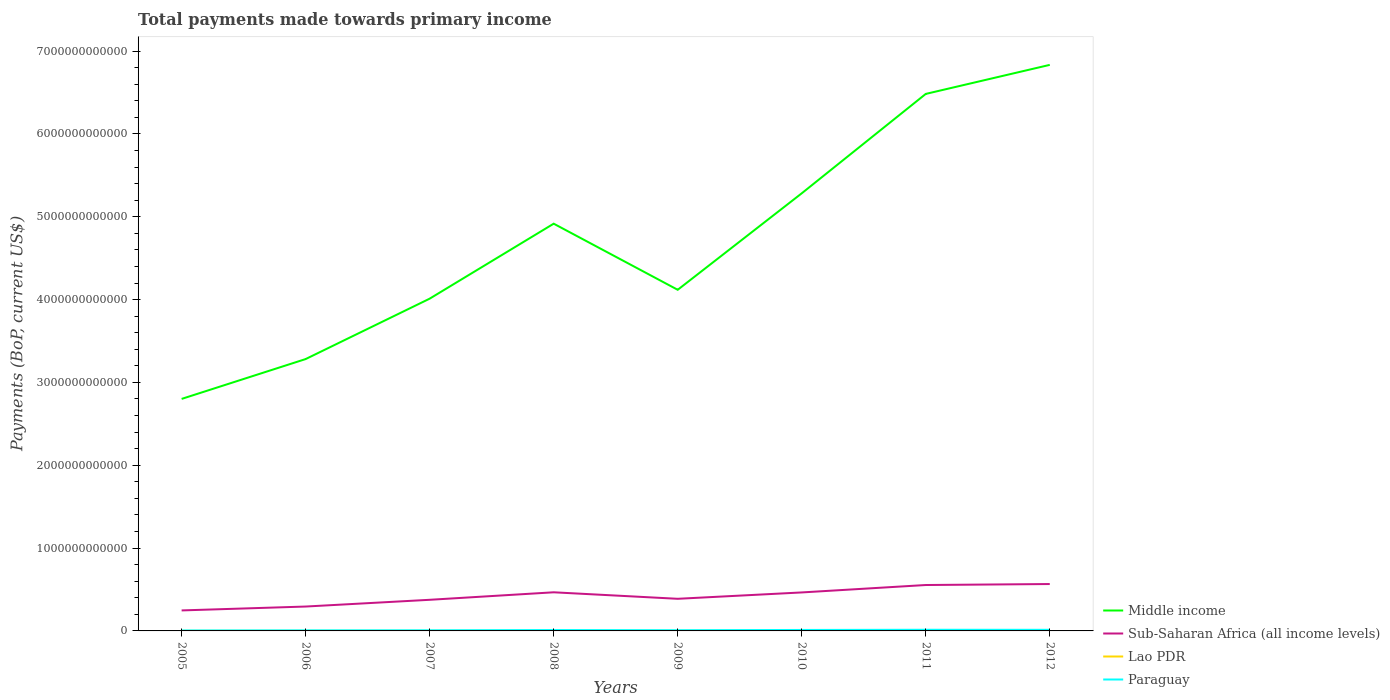How many different coloured lines are there?
Your answer should be compact. 4. Does the line corresponding to Middle income intersect with the line corresponding to Paraguay?
Offer a terse response. No. Across all years, what is the maximum total payments made towards primary income in Sub-Saharan Africa (all income levels)?
Provide a succinct answer. 2.47e+11. In which year was the total payments made towards primary income in Lao PDR maximum?
Make the answer very short. 2005. What is the total total payments made towards primary income in Lao PDR in the graph?
Make the answer very short. -1.12e+09. What is the difference between the highest and the second highest total payments made towards primary income in Middle income?
Your answer should be compact. 4.03e+12. Is the total payments made towards primary income in Middle income strictly greater than the total payments made towards primary income in Lao PDR over the years?
Offer a very short reply. No. How many years are there in the graph?
Offer a very short reply. 8. What is the difference between two consecutive major ticks on the Y-axis?
Offer a very short reply. 1.00e+12. Are the values on the major ticks of Y-axis written in scientific E-notation?
Your response must be concise. No. Does the graph contain grids?
Keep it short and to the point. No. How many legend labels are there?
Make the answer very short. 4. What is the title of the graph?
Your answer should be very brief. Total payments made towards primary income. Does "Poland" appear as one of the legend labels in the graph?
Your response must be concise. No. What is the label or title of the X-axis?
Your response must be concise. Years. What is the label or title of the Y-axis?
Ensure brevity in your answer.  Payments (BoP, current US$). What is the Payments (BoP, current US$) of Middle income in 2005?
Give a very brief answer. 2.80e+12. What is the Payments (BoP, current US$) of Sub-Saharan Africa (all income levels) in 2005?
Your answer should be compact. 2.47e+11. What is the Payments (BoP, current US$) in Lao PDR in 2005?
Provide a short and direct response. 1.00e+09. What is the Payments (BoP, current US$) in Paraguay in 2005?
Your answer should be very brief. 5.47e+09. What is the Payments (BoP, current US$) in Middle income in 2006?
Keep it short and to the point. 3.28e+12. What is the Payments (BoP, current US$) of Sub-Saharan Africa (all income levels) in 2006?
Provide a succinct answer. 2.94e+11. What is the Payments (BoP, current US$) in Lao PDR in 2006?
Give a very brief answer. 1.17e+09. What is the Payments (BoP, current US$) of Paraguay in 2006?
Your answer should be very brief. 6.70e+09. What is the Payments (BoP, current US$) in Middle income in 2007?
Keep it short and to the point. 4.01e+12. What is the Payments (BoP, current US$) of Sub-Saharan Africa (all income levels) in 2007?
Ensure brevity in your answer.  3.76e+11. What is the Payments (BoP, current US$) of Lao PDR in 2007?
Make the answer very short. 1.20e+09. What is the Payments (BoP, current US$) in Paraguay in 2007?
Keep it short and to the point. 7.56e+09. What is the Payments (BoP, current US$) of Middle income in 2008?
Make the answer very short. 4.92e+12. What is the Payments (BoP, current US$) of Sub-Saharan Africa (all income levels) in 2008?
Make the answer very short. 4.66e+11. What is the Payments (BoP, current US$) of Lao PDR in 2008?
Your answer should be compact. 1.59e+09. What is the Payments (BoP, current US$) of Paraguay in 2008?
Make the answer very short. 1.05e+1. What is the Payments (BoP, current US$) in Middle income in 2009?
Your response must be concise. 4.12e+12. What is the Payments (BoP, current US$) of Sub-Saharan Africa (all income levels) in 2009?
Make the answer very short. 3.88e+11. What is the Payments (BoP, current US$) in Lao PDR in 2009?
Keep it short and to the point. 1.69e+09. What is the Payments (BoP, current US$) of Paraguay in 2009?
Provide a succinct answer. 8.42e+09. What is the Payments (BoP, current US$) of Middle income in 2010?
Provide a succinct answer. 5.28e+12. What is the Payments (BoP, current US$) of Sub-Saharan Africa (all income levels) in 2010?
Offer a terse response. 4.65e+11. What is the Payments (BoP, current US$) in Lao PDR in 2010?
Offer a very short reply. 2.46e+09. What is the Payments (BoP, current US$) in Paraguay in 2010?
Give a very brief answer. 1.17e+1. What is the Payments (BoP, current US$) of Middle income in 2011?
Provide a short and direct response. 6.48e+12. What is the Payments (BoP, current US$) of Sub-Saharan Africa (all income levels) in 2011?
Give a very brief answer. 5.54e+11. What is the Payments (BoP, current US$) in Lao PDR in 2011?
Provide a short and direct response. 2.88e+09. What is the Payments (BoP, current US$) of Paraguay in 2011?
Make the answer very short. 1.39e+1. What is the Payments (BoP, current US$) of Middle income in 2012?
Make the answer very short. 6.83e+12. What is the Payments (BoP, current US$) of Sub-Saharan Africa (all income levels) in 2012?
Offer a very short reply. 5.66e+11. What is the Payments (BoP, current US$) of Lao PDR in 2012?
Your answer should be very brief. 3.58e+09. What is the Payments (BoP, current US$) of Paraguay in 2012?
Offer a very short reply. 1.34e+1. Across all years, what is the maximum Payments (BoP, current US$) of Middle income?
Ensure brevity in your answer.  6.83e+12. Across all years, what is the maximum Payments (BoP, current US$) of Sub-Saharan Africa (all income levels)?
Your answer should be very brief. 5.66e+11. Across all years, what is the maximum Payments (BoP, current US$) of Lao PDR?
Provide a succinct answer. 3.58e+09. Across all years, what is the maximum Payments (BoP, current US$) in Paraguay?
Keep it short and to the point. 1.39e+1. Across all years, what is the minimum Payments (BoP, current US$) in Middle income?
Provide a succinct answer. 2.80e+12. Across all years, what is the minimum Payments (BoP, current US$) of Sub-Saharan Africa (all income levels)?
Make the answer very short. 2.47e+11. Across all years, what is the minimum Payments (BoP, current US$) in Lao PDR?
Make the answer very short. 1.00e+09. Across all years, what is the minimum Payments (BoP, current US$) in Paraguay?
Offer a very short reply. 5.47e+09. What is the total Payments (BoP, current US$) in Middle income in the graph?
Offer a terse response. 3.77e+13. What is the total Payments (BoP, current US$) of Sub-Saharan Africa (all income levels) in the graph?
Offer a very short reply. 3.36e+12. What is the total Payments (BoP, current US$) of Lao PDR in the graph?
Give a very brief answer. 1.56e+1. What is the total Payments (BoP, current US$) in Paraguay in the graph?
Give a very brief answer. 7.77e+1. What is the difference between the Payments (BoP, current US$) of Middle income in 2005 and that in 2006?
Offer a very short reply. -4.81e+11. What is the difference between the Payments (BoP, current US$) of Sub-Saharan Africa (all income levels) in 2005 and that in 2006?
Ensure brevity in your answer.  -4.69e+1. What is the difference between the Payments (BoP, current US$) of Lao PDR in 2005 and that in 2006?
Provide a short and direct response. -1.70e+08. What is the difference between the Payments (BoP, current US$) of Paraguay in 2005 and that in 2006?
Your answer should be compact. -1.23e+09. What is the difference between the Payments (BoP, current US$) in Middle income in 2005 and that in 2007?
Offer a terse response. -1.21e+12. What is the difference between the Payments (BoP, current US$) of Sub-Saharan Africa (all income levels) in 2005 and that in 2007?
Your response must be concise. -1.28e+11. What is the difference between the Payments (BoP, current US$) in Lao PDR in 2005 and that in 2007?
Provide a succinct answer. -1.99e+08. What is the difference between the Payments (BoP, current US$) of Paraguay in 2005 and that in 2007?
Offer a very short reply. -2.09e+09. What is the difference between the Payments (BoP, current US$) of Middle income in 2005 and that in 2008?
Give a very brief answer. -2.12e+12. What is the difference between the Payments (BoP, current US$) of Sub-Saharan Africa (all income levels) in 2005 and that in 2008?
Offer a terse response. -2.19e+11. What is the difference between the Payments (BoP, current US$) in Lao PDR in 2005 and that in 2008?
Make the answer very short. -5.85e+08. What is the difference between the Payments (BoP, current US$) in Paraguay in 2005 and that in 2008?
Ensure brevity in your answer.  -5.04e+09. What is the difference between the Payments (BoP, current US$) of Middle income in 2005 and that in 2009?
Your response must be concise. -1.32e+12. What is the difference between the Payments (BoP, current US$) of Sub-Saharan Africa (all income levels) in 2005 and that in 2009?
Offer a terse response. -1.40e+11. What is the difference between the Payments (BoP, current US$) of Lao PDR in 2005 and that in 2009?
Offer a terse response. -6.82e+08. What is the difference between the Payments (BoP, current US$) of Paraguay in 2005 and that in 2009?
Give a very brief answer. -2.95e+09. What is the difference between the Payments (BoP, current US$) of Middle income in 2005 and that in 2010?
Your response must be concise. -2.48e+12. What is the difference between the Payments (BoP, current US$) of Sub-Saharan Africa (all income levels) in 2005 and that in 2010?
Make the answer very short. -2.17e+11. What is the difference between the Payments (BoP, current US$) in Lao PDR in 2005 and that in 2010?
Keep it short and to the point. -1.45e+09. What is the difference between the Payments (BoP, current US$) in Paraguay in 2005 and that in 2010?
Your answer should be very brief. -6.28e+09. What is the difference between the Payments (BoP, current US$) in Middle income in 2005 and that in 2011?
Your answer should be compact. -3.68e+12. What is the difference between the Payments (BoP, current US$) of Sub-Saharan Africa (all income levels) in 2005 and that in 2011?
Give a very brief answer. -3.07e+11. What is the difference between the Payments (BoP, current US$) of Lao PDR in 2005 and that in 2011?
Your answer should be very brief. -1.88e+09. What is the difference between the Payments (BoP, current US$) in Paraguay in 2005 and that in 2011?
Keep it short and to the point. -8.47e+09. What is the difference between the Payments (BoP, current US$) in Middle income in 2005 and that in 2012?
Your answer should be compact. -4.03e+12. What is the difference between the Payments (BoP, current US$) in Sub-Saharan Africa (all income levels) in 2005 and that in 2012?
Provide a short and direct response. -3.19e+11. What is the difference between the Payments (BoP, current US$) in Lao PDR in 2005 and that in 2012?
Keep it short and to the point. -2.58e+09. What is the difference between the Payments (BoP, current US$) in Paraguay in 2005 and that in 2012?
Ensure brevity in your answer.  -7.90e+09. What is the difference between the Payments (BoP, current US$) of Middle income in 2006 and that in 2007?
Your answer should be very brief. -7.29e+11. What is the difference between the Payments (BoP, current US$) in Sub-Saharan Africa (all income levels) in 2006 and that in 2007?
Give a very brief answer. -8.13e+1. What is the difference between the Payments (BoP, current US$) in Lao PDR in 2006 and that in 2007?
Your answer should be very brief. -2.94e+07. What is the difference between the Payments (BoP, current US$) in Paraguay in 2006 and that in 2007?
Ensure brevity in your answer.  -8.62e+08. What is the difference between the Payments (BoP, current US$) in Middle income in 2006 and that in 2008?
Offer a terse response. -1.63e+12. What is the difference between the Payments (BoP, current US$) of Sub-Saharan Africa (all income levels) in 2006 and that in 2008?
Keep it short and to the point. -1.72e+11. What is the difference between the Payments (BoP, current US$) in Lao PDR in 2006 and that in 2008?
Provide a succinct answer. -4.16e+08. What is the difference between the Payments (BoP, current US$) in Paraguay in 2006 and that in 2008?
Provide a short and direct response. -3.81e+09. What is the difference between the Payments (BoP, current US$) of Middle income in 2006 and that in 2009?
Provide a succinct answer. -8.36e+11. What is the difference between the Payments (BoP, current US$) in Sub-Saharan Africa (all income levels) in 2006 and that in 2009?
Offer a terse response. -9.35e+1. What is the difference between the Payments (BoP, current US$) in Lao PDR in 2006 and that in 2009?
Keep it short and to the point. -5.12e+08. What is the difference between the Payments (BoP, current US$) in Paraguay in 2006 and that in 2009?
Provide a short and direct response. -1.72e+09. What is the difference between the Payments (BoP, current US$) of Middle income in 2006 and that in 2010?
Keep it short and to the point. -2.00e+12. What is the difference between the Payments (BoP, current US$) of Sub-Saharan Africa (all income levels) in 2006 and that in 2010?
Offer a very short reply. -1.70e+11. What is the difference between the Payments (BoP, current US$) of Lao PDR in 2006 and that in 2010?
Offer a terse response. -1.28e+09. What is the difference between the Payments (BoP, current US$) in Paraguay in 2006 and that in 2010?
Your response must be concise. -5.05e+09. What is the difference between the Payments (BoP, current US$) in Middle income in 2006 and that in 2011?
Give a very brief answer. -3.20e+12. What is the difference between the Payments (BoP, current US$) in Sub-Saharan Africa (all income levels) in 2006 and that in 2011?
Your response must be concise. -2.60e+11. What is the difference between the Payments (BoP, current US$) of Lao PDR in 2006 and that in 2011?
Offer a very short reply. -1.71e+09. What is the difference between the Payments (BoP, current US$) in Paraguay in 2006 and that in 2011?
Your answer should be compact. -7.24e+09. What is the difference between the Payments (BoP, current US$) of Middle income in 2006 and that in 2012?
Ensure brevity in your answer.  -3.55e+12. What is the difference between the Payments (BoP, current US$) in Sub-Saharan Africa (all income levels) in 2006 and that in 2012?
Your answer should be compact. -2.72e+11. What is the difference between the Payments (BoP, current US$) in Lao PDR in 2006 and that in 2012?
Ensure brevity in your answer.  -2.41e+09. What is the difference between the Payments (BoP, current US$) of Paraguay in 2006 and that in 2012?
Offer a very short reply. -6.67e+09. What is the difference between the Payments (BoP, current US$) of Middle income in 2007 and that in 2008?
Ensure brevity in your answer.  -9.05e+11. What is the difference between the Payments (BoP, current US$) of Sub-Saharan Africa (all income levels) in 2007 and that in 2008?
Make the answer very short. -9.06e+1. What is the difference between the Payments (BoP, current US$) in Lao PDR in 2007 and that in 2008?
Make the answer very short. -3.86e+08. What is the difference between the Payments (BoP, current US$) in Paraguay in 2007 and that in 2008?
Your answer should be compact. -2.94e+09. What is the difference between the Payments (BoP, current US$) in Middle income in 2007 and that in 2009?
Ensure brevity in your answer.  -1.07e+11. What is the difference between the Payments (BoP, current US$) in Sub-Saharan Africa (all income levels) in 2007 and that in 2009?
Your response must be concise. -1.22e+1. What is the difference between the Payments (BoP, current US$) in Lao PDR in 2007 and that in 2009?
Your answer should be very brief. -4.83e+08. What is the difference between the Payments (BoP, current US$) of Paraguay in 2007 and that in 2009?
Your answer should be very brief. -8.59e+08. What is the difference between the Payments (BoP, current US$) in Middle income in 2007 and that in 2010?
Your response must be concise. -1.27e+12. What is the difference between the Payments (BoP, current US$) in Sub-Saharan Africa (all income levels) in 2007 and that in 2010?
Your response must be concise. -8.89e+1. What is the difference between the Payments (BoP, current US$) in Lao PDR in 2007 and that in 2010?
Your answer should be compact. -1.25e+09. What is the difference between the Payments (BoP, current US$) of Paraguay in 2007 and that in 2010?
Your answer should be very brief. -4.19e+09. What is the difference between the Payments (BoP, current US$) in Middle income in 2007 and that in 2011?
Provide a short and direct response. -2.47e+12. What is the difference between the Payments (BoP, current US$) in Sub-Saharan Africa (all income levels) in 2007 and that in 2011?
Offer a very short reply. -1.79e+11. What is the difference between the Payments (BoP, current US$) in Lao PDR in 2007 and that in 2011?
Keep it short and to the point. -1.68e+09. What is the difference between the Payments (BoP, current US$) in Paraguay in 2007 and that in 2011?
Ensure brevity in your answer.  -6.38e+09. What is the difference between the Payments (BoP, current US$) of Middle income in 2007 and that in 2012?
Keep it short and to the point. -2.82e+12. What is the difference between the Payments (BoP, current US$) in Sub-Saharan Africa (all income levels) in 2007 and that in 2012?
Make the answer very short. -1.90e+11. What is the difference between the Payments (BoP, current US$) in Lao PDR in 2007 and that in 2012?
Offer a very short reply. -2.38e+09. What is the difference between the Payments (BoP, current US$) in Paraguay in 2007 and that in 2012?
Give a very brief answer. -5.81e+09. What is the difference between the Payments (BoP, current US$) of Middle income in 2008 and that in 2009?
Your answer should be compact. 7.98e+11. What is the difference between the Payments (BoP, current US$) of Sub-Saharan Africa (all income levels) in 2008 and that in 2009?
Offer a terse response. 7.84e+1. What is the difference between the Payments (BoP, current US$) of Lao PDR in 2008 and that in 2009?
Keep it short and to the point. -9.67e+07. What is the difference between the Payments (BoP, current US$) in Paraguay in 2008 and that in 2009?
Offer a very short reply. 2.09e+09. What is the difference between the Payments (BoP, current US$) of Middle income in 2008 and that in 2010?
Keep it short and to the point. -3.67e+11. What is the difference between the Payments (BoP, current US$) of Sub-Saharan Africa (all income levels) in 2008 and that in 2010?
Ensure brevity in your answer.  1.75e+09. What is the difference between the Payments (BoP, current US$) of Lao PDR in 2008 and that in 2010?
Provide a succinct answer. -8.68e+08. What is the difference between the Payments (BoP, current US$) of Paraguay in 2008 and that in 2010?
Make the answer very short. -1.24e+09. What is the difference between the Payments (BoP, current US$) in Middle income in 2008 and that in 2011?
Ensure brevity in your answer.  -1.57e+12. What is the difference between the Payments (BoP, current US$) of Sub-Saharan Africa (all income levels) in 2008 and that in 2011?
Make the answer very short. -8.79e+1. What is the difference between the Payments (BoP, current US$) in Lao PDR in 2008 and that in 2011?
Keep it short and to the point. -1.29e+09. What is the difference between the Payments (BoP, current US$) of Paraguay in 2008 and that in 2011?
Ensure brevity in your answer.  -3.43e+09. What is the difference between the Payments (BoP, current US$) of Middle income in 2008 and that in 2012?
Your answer should be very brief. -1.92e+12. What is the difference between the Payments (BoP, current US$) of Sub-Saharan Africa (all income levels) in 2008 and that in 2012?
Offer a very short reply. -9.98e+1. What is the difference between the Payments (BoP, current US$) in Lao PDR in 2008 and that in 2012?
Provide a short and direct response. -1.99e+09. What is the difference between the Payments (BoP, current US$) of Paraguay in 2008 and that in 2012?
Provide a succinct answer. -2.87e+09. What is the difference between the Payments (BoP, current US$) in Middle income in 2009 and that in 2010?
Ensure brevity in your answer.  -1.16e+12. What is the difference between the Payments (BoP, current US$) of Sub-Saharan Africa (all income levels) in 2009 and that in 2010?
Offer a terse response. -7.67e+1. What is the difference between the Payments (BoP, current US$) of Lao PDR in 2009 and that in 2010?
Your response must be concise. -7.72e+08. What is the difference between the Payments (BoP, current US$) of Paraguay in 2009 and that in 2010?
Keep it short and to the point. -3.33e+09. What is the difference between the Payments (BoP, current US$) of Middle income in 2009 and that in 2011?
Your response must be concise. -2.36e+12. What is the difference between the Payments (BoP, current US$) of Sub-Saharan Africa (all income levels) in 2009 and that in 2011?
Keep it short and to the point. -1.66e+11. What is the difference between the Payments (BoP, current US$) of Lao PDR in 2009 and that in 2011?
Your answer should be compact. -1.20e+09. What is the difference between the Payments (BoP, current US$) of Paraguay in 2009 and that in 2011?
Offer a terse response. -5.52e+09. What is the difference between the Payments (BoP, current US$) in Middle income in 2009 and that in 2012?
Ensure brevity in your answer.  -2.72e+12. What is the difference between the Payments (BoP, current US$) of Sub-Saharan Africa (all income levels) in 2009 and that in 2012?
Your response must be concise. -1.78e+11. What is the difference between the Payments (BoP, current US$) in Lao PDR in 2009 and that in 2012?
Your answer should be compact. -1.90e+09. What is the difference between the Payments (BoP, current US$) in Paraguay in 2009 and that in 2012?
Provide a succinct answer. -4.95e+09. What is the difference between the Payments (BoP, current US$) in Middle income in 2010 and that in 2011?
Offer a terse response. -1.20e+12. What is the difference between the Payments (BoP, current US$) in Sub-Saharan Africa (all income levels) in 2010 and that in 2011?
Keep it short and to the point. -8.97e+1. What is the difference between the Payments (BoP, current US$) of Lao PDR in 2010 and that in 2011?
Provide a succinct answer. -4.24e+08. What is the difference between the Payments (BoP, current US$) in Paraguay in 2010 and that in 2011?
Provide a short and direct response. -2.19e+09. What is the difference between the Payments (BoP, current US$) of Middle income in 2010 and that in 2012?
Provide a succinct answer. -1.55e+12. What is the difference between the Payments (BoP, current US$) in Sub-Saharan Africa (all income levels) in 2010 and that in 2012?
Keep it short and to the point. -1.02e+11. What is the difference between the Payments (BoP, current US$) in Lao PDR in 2010 and that in 2012?
Keep it short and to the point. -1.12e+09. What is the difference between the Payments (BoP, current US$) in Paraguay in 2010 and that in 2012?
Provide a succinct answer. -1.62e+09. What is the difference between the Payments (BoP, current US$) of Middle income in 2011 and that in 2012?
Give a very brief answer. -3.51e+11. What is the difference between the Payments (BoP, current US$) in Sub-Saharan Africa (all income levels) in 2011 and that in 2012?
Offer a terse response. -1.19e+1. What is the difference between the Payments (BoP, current US$) of Lao PDR in 2011 and that in 2012?
Provide a short and direct response. -7.01e+08. What is the difference between the Payments (BoP, current US$) of Paraguay in 2011 and that in 2012?
Give a very brief answer. 5.66e+08. What is the difference between the Payments (BoP, current US$) in Middle income in 2005 and the Payments (BoP, current US$) in Sub-Saharan Africa (all income levels) in 2006?
Keep it short and to the point. 2.51e+12. What is the difference between the Payments (BoP, current US$) of Middle income in 2005 and the Payments (BoP, current US$) of Lao PDR in 2006?
Provide a succinct answer. 2.80e+12. What is the difference between the Payments (BoP, current US$) in Middle income in 2005 and the Payments (BoP, current US$) in Paraguay in 2006?
Ensure brevity in your answer.  2.79e+12. What is the difference between the Payments (BoP, current US$) in Sub-Saharan Africa (all income levels) in 2005 and the Payments (BoP, current US$) in Lao PDR in 2006?
Provide a succinct answer. 2.46e+11. What is the difference between the Payments (BoP, current US$) in Sub-Saharan Africa (all income levels) in 2005 and the Payments (BoP, current US$) in Paraguay in 2006?
Your response must be concise. 2.41e+11. What is the difference between the Payments (BoP, current US$) of Lao PDR in 2005 and the Payments (BoP, current US$) of Paraguay in 2006?
Offer a terse response. -5.70e+09. What is the difference between the Payments (BoP, current US$) in Middle income in 2005 and the Payments (BoP, current US$) in Sub-Saharan Africa (all income levels) in 2007?
Your response must be concise. 2.43e+12. What is the difference between the Payments (BoP, current US$) in Middle income in 2005 and the Payments (BoP, current US$) in Lao PDR in 2007?
Provide a short and direct response. 2.80e+12. What is the difference between the Payments (BoP, current US$) in Middle income in 2005 and the Payments (BoP, current US$) in Paraguay in 2007?
Your answer should be very brief. 2.79e+12. What is the difference between the Payments (BoP, current US$) of Sub-Saharan Africa (all income levels) in 2005 and the Payments (BoP, current US$) of Lao PDR in 2007?
Keep it short and to the point. 2.46e+11. What is the difference between the Payments (BoP, current US$) in Sub-Saharan Africa (all income levels) in 2005 and the Payments (BoP, current US$) in Paraguay in 2007?
Offer a very short reply. 2.40e+11. What is the difference between the Payments (BoP, current US$) in Lao PDR in 2005 and the Payments (BoP, current US$) in Paraguay in 2007?
Offer a very short reply. -6.56e+09. What is the difference between the Payments (BoP, current US$) of Middle income in 2005 and the Payments (BoP, current US$) of Sub-Saharan Africa (all income levels) in 2008?
Your answer should be compact. 2.33e+12. What is the difference between the Payments (BoP, current US$) of Middle income in 2005 and the Payments (BoP, current US$) of Lao PDR in 2008?
Your answer should be very brief. 2.80e+12. What is the difference between the Payments (BoP, current US$) in Middle income in 2005 and the Payments (BoP, current US$) in Paraguay in 2008?
Your answer should be compact. 2.79e+12. What is the difference between the Payments (BoP, current US$) of Sub-Saharan Africa (all income levels) in 2005 and the Payments (BoP, current US$) of Lao PDR in 2008?
Offer a very short reply. 2.46e+11. What is the difference between the Payments (BoP, current US$) of Sub-Saharan Africa (all income levels) in 2005 and the Payments (BoP, current US$) of Paraguay in 2008?
Make the answer very short. 2.37e+11. What is the difference between the Payments (BoP, current US$) of Lao PDR in 2005 and the Payments (BoP, current US$) of Paraguay in 2008?
Offer a terse response. -9.51e+09. What is the difference between the Payments (BoP, current US$) in Middle income in 2005 and the Payments (BoP, current US$) in Sub-Saharan Africa (all income levels) in 2009?
Make the answer very short. 2.41e+12. What is the difference between the Payments (BoP, current US$) in Middle income in 2005 and the Payments (BoP, current US$) in Lao PDR in 2009?
Keep it short and to the point. 2.80e+12. What is the difference between the Payments (BoP, current US$) of Middle income in 2005 and the Payments (BoP, current US$) of Paraguay in 2009?
Make the answer very short. 2.79e+12. What is the difference between the Payments (BoP, current US$) of Sub-Saharan Africa (all income levels) in 2005 and the Payments (BoP, current US$) of Lao PDR in 2009?
Your answer should be very brief. 2.46e+11. What is the difference between the Payments (BoP, current US$) in Sub-Saharan Africa (all income levels) in 2005 and the Payments (BoP, current US$) in Paraguay in 2009?
Give a very brief answer. 2.39e+11. What is the difference between the Payments (BoP, current US$) in Lao PDR in 2005 and the Payments (BoP, current US$) in Paraguay in 2009?
Give a very brief answer. -7.42e+09. What is the difference between the Payments (BoP, current US$) of Middle income in 2005 and the Payments (BoP, current US$) of Sub-Saharan Africa (all income levels) in 2010?
Provide a short and direct response. 2.34e+12. What is the difference between the Payments (BoP, current US$) in Middle income in 2005 and the Payments (BoP, current US$) in Lao PDR in 2010?
Your response must be concise. 2.80e+12. What is the difference between the Payments (BoP, current US$) of Middle income in 2005 and the Payments (BoP, current US$) of Paraguay in 2010?
Offer a very short reply. 2.79e+12. What is the difference between the Payments (BoP, current US$) of Sub-Saharan Africa (all income levels) in 2005 and the Payments (BoP, current US$) of Lao PDR in 2010?
Your answer should be compact. 2.45e+11. What is the difference between the Payments (BoP, current US$) in Sub-Saharan Africa (all income levels) in 2005 and the Payments (BoP, current US$) in Paraguay in 2010?
Give a very brief answer. 2.36e+11. What is the difference between the Payments (BoP, current US$) of Lao PDR in 2005 and the Payments (BoP, current US$) of Paraguay in 2010?
Your answer should be compact. -1.07e+1. What is the difference between the Payments (BoP, current US$) in Middle income in 2005 and the Payments (BoP, current US$) in Sub-Saharan Africa (all income levels) in 2011?
Provide a short and direct response. 2.25e+12. What is the difference between the Payments (BoP, current US$) of Middle income in 2005 and the Payments (BoP, current US$) of Lao PDR in 2011?
Keep it short and to the point. 2.80e+12. What is the difference between the Payments (BoP, current US$) in Middle income in 2005 and the Payments (BoP, current US$) in Paraguay in 2011?
Your answer should be very brief. 2.79e+12. What is the difference between the Payments (BoP, current US$) of Sub-Saharan Africa (all income levels) in 2005 and the Payments (BoP, current US$) of Lao PDR in 2011?
Ensure brevity in your answer.  2.45e+11. What is the difference between the Payments (BoP, current US$) in Sub-Saharan Africa (all income levels) in 2005 and the Payments (BoP, current US$) in Paraguay in 2011?
Ensure brevity in your answer.  2.33e+11. What is the difference between the Payments (BoP, current US$) in Lao PDR in 2005 and the Payments (BoP, current US$) in Paraguay in 2011?
Keep it short and to the point. -1.29e+1. What is the difference between the Payments (BoP, current US$) in Middle income in 2005 and the Payments (BoP, current US$) in Sub-Saharan Africa (all income levels) in 2012?
Ensure brevity in your answer.  2.23e+12. What is the difference between the Payments (BoP, current US$) of Middle income in 2005 and the Payments (BoP, current US$) of Lao PDR in 2012?
Keep it short and to the point. 2.80e+12. What is the difference between the Payments (BoP, current US$) in Middle income in 2005 and the Payments (BoP, current US$) in Paraguay in 2012?
Ensure brevity in your answer.  2.79e+12. What is the difference between the Payments (BoP, current US$) of Sub-Saharan Africa (all income levels) in 2005 and the Payments (BoP, current US$) of Lao PDR in 2012?
Make the answer very short. 2.44e+11. What is the difference between the Payments (BoP, current US$) of Sub-Saharan Africa (all income levels) in 2005 and the Payments (BoP, current US$) of Paraguay in 2012?
Offer a very short reply. 2.34e+11. What is the difference between the Payments (BoP, current US$) in Lao PDR in 2005 and the Payments (BoP, current US$) in Paraguay in 2012?
Your response must be concise. -1.24e+1. What is the difference between the Payments (BoP, current US$) in Middle income in 2006 and the Payments (BoP, current US$) in Sub-Saharan Africa (all income levels) in 2007?
Offer a terse response. 2.91e+12. What is the difference between the Payments (BoP, current US$) in Middle income in 2006 and the Payments (BoP, current US$) in Lao PDR in 2007?
Give a very brief answer. 3.28e+12. What is the difference between the Payments (BoP, current US$) in Middle income in 2006 and the Payments (BoP, current US$) in Paraguay in 2007?
Provide a succinct answer. 3.27e+12. What is the difference between the Payments (BoP, current US$) of Sub-Saharan Africa (all income levels) in 2006 and the Payments (BoP, current US$) of Lao PDR in 2007?
Give a very brief answer. 2.93e+11. What is the difference between the Payments (BoP, current US$) in Sub-Saharan Africa (all income levels) in 2006 and the Payments (BoP, current US$) in Paraguay in 2007?
Your answer should be compact. 2.87e+11. What is the difference between the Payments (BoP, current US$) of Lao PDR in 2006 and the Payments (BoP, current US$) of Paraguay in 2007?
Provide a short and direct response. -6.39e+09. What is the difference between the Payments (BoP, current US$) of Middle income in 2006 and the Payments (BoP, current US$) of Sub-Saharan Africa (all income levels) in 2008?
Offer a very short reply. 2.82e+12. What is the difference between the Payments (BoP, current US$) of Middle income in 2006 and the Payments (BoP, current US$) of Lao PDR in 2008?
Your answer should be very brief. 3.28e+12. What is the difference between the Payments (BoP, current US$) in Middle income in 2006 and the Payments (BoP, current US$) in Paraguay in 2008?
Offer a terse response. 3.27e+12. What is the difference between the Payments (BoP, current US$) of Sub-Saharan Africa (all income levels) in 2006 and the Payments (BoP, current US$) of Lao PDR in 2008?
Provide a short and direct response. 2.93e+11. What is the difference between the Payments (BoP, current US$) of Sub-Saharan Africa (all income levels) in 2006 and the Payments (BoP, current US$) of Paraguay in 2008?
Provide a short and direct response. 2.84e+11. What is the difference between the Payments (BoP, current US$) in Lao PDR in 2006 and the Payments (BoP, current US$) in Paraguay in 2008?
Your answer should be compact. -9.34e+09. What is the difference between the Payments (BoP, current US$) in Middle income in 2006 and the Payments (BoP, current US$) in Sub-Saharan Africa (all income levels) in 2009?
Your answer should be very brief. 2.89e+12. What is the difference between the Payments (BoP, current US$) in Middle income in 2006 and the Payments (BoP, current US$) in Lao PDR in 2009?
Provide a succinct answer. 3.28e+12. What is the difference between the Payments (BoP, current US$) of Middle income in 2006 and the Payments (BoP, current US$) of Paraguay in 2009?
Ensure brevity in your answer.  3.27e+12. What is the difference between the Payments (BoP, current US$) in Sub-Saharan Africa (all income levels) in 2006 and the Payments (BoP, current US$) in Lao PDR in 2009?
Make the answer very short. 2.93e+11. What is the difference between the Payments (BoP, current US$) of Sub-Saharan Africa (all income levels) in 2006 and the Payments (BoP, current US$) of Paraguay in 2009?
Ensure brevity in your answer.  2.86e+11. What is the difference between the Payments (BoP, current US$) in Lao PDR in 2006 and the Payments (BoP, current US$) in Paraguay in 2009?
Offer a terse response. -7.25e+09. What is the difference between the Payments (BoP, current US$) of Middle income in 2006 and the Payments (BoP, current US$) of Sub-Saharan Africa (all income levels) in 2010?
Offer a terse response. 2.82e+12. What is the difference between the Payments (BoP, current US$) in Middle income in 2006 and the Payments (BoP, current US$) in Lao PDR in 2010?
Keep it short and to the point. 3.28e+12. What is the difference between the Payments (BoP, current US$) in Middle income in 2006 and the Payments (BoP, current US$) in Paraguay in 2010?
Your response must be concise. 3.27e+12. What is the difference between the Payments (BoP, current US$) of Sub-Saharan Africa (all income levels) in 2006 and the Payments (BoP, current US$) of Lao PDR in 2010?
Your answer should be compact. 2.92e+11. What is the difference between the Payments (BoP, current US$) of Sub-Saharan Africa (all income levels) in 2006 and the Payments (BoP, current US$) of Paraguay in 2010?
Make the answer very short. 2.83e+11. What is the difference between the Payments (BoP, current US$) of Lao PDR in 2006 and the Payments (BoP, current US$) of Paraguay in 2010?
Your response must be concise. -1.06e+1. What is the difference between the Payments (BoP, current US$) in Middle income in 2006 and the Payments (BoP, current US$) in Sub-Saharan Africa (all income levels) in 2011?
Give a very brief answer. 2.73e+12. What is the difference between the Payments (BoP, current US$) in Middle income in 2006 and the Payments (BoP, current US$) in Lao PDR in 2011?
Offer a very short reply. 3.28e+12. What is the difference between the Payments (BoP, current US$) of Middle income in 2006 and the Payments (BoP, current US$) of Paraguay in 2011?
Your answer should be compact. 3.27e+12. What is the difference between the Payments (BoP, current US$) of Sub-Saharan Africa (all income levels) in 2006 and the Payments (BoP, current US$) of Lao PDR in 2011?
Provide a succinct answer. 2.91e+11. What is the difference between the Payments (BoP, current US$) of Sub-Saharan Africa (all income levels) in 2006 and the Payments (BoP, current US$) of Paraguay in 2011?
Keep it short and to the point. 2.80e+11. What is the difference between the Payments (BoP, current US$) in Lao PDR in 2006 and the Payments (BoP, current US$) in Paraguay in 2011?
Provide a succinct answer. -1.28e+1. What is the difference between the Payments (BoP, current US$) of Middle income in 2006 and the Payments (BoP, current US$) of Sub-Saharan Africa (all income levels) in 2012?
Keep it short and to the point. 2.72e+12. What is the difference between the Payments (BoP, current US$) in Middle income in 2006 and the Payments (BoP, current US$) in Lao PDR in 2012?
Ensure brevity in your answer.  3.28e+12. What is the difference between the Payments (BoP, current US$) in Middle income in 2006 and the Payments (BoP, current US$) in Paraguay in 2012?
Provide a short and direct response. 3.27e+12. What is the difference between the Payments (BoP, current US$) in Sub-Saharan Africa (all income levels) in 2006 and the Payments (BoP, current US$) in Lao PDR in 2012?
Offer a very short reply. 2.91e+11. What is the difference between the Payments (BoP, current US$) of Sub-Saharan Africa (all income levels) in 2006 and the Payments (BoP, current US$) of Paraguay in 2012?
Provide a short and direct response. 2.81e+11. What is the difference between the Payments (BoP, current US$) of Lao PDR in 2006 and the Payments (BoP, current US$) of Paraguay in 2012?
Make the answer very short. -1.22e+1. What is the difference between the Payments (BoP, current US$) in Middle income in 2007 and the Payments (BoP, current US$) in Sub-Saharan Africa (all income levels) in 2008?
Provide a short and direct response. 3.54e+12. What is the difference between the Payments (BoP, current US$) of Middle income in 2007 and the Payments (BoP, current US$) of Lao PDR in 2008?
Make the answer very short. 4.01e+12. What is the difference between the Payments (BoP, current US$) of Middle income in 2007 and the Payments (BoP, current US$) of Paraguay in 2008?
Offer a terse response. 4.00e+12. What is the difference between the Payments (BoP, current US$) of Sub-Saharan Africa (all income levels) in 2007 and the Payments (BoP, current US$) of Lao PDR in 2008?
Provide a succinct answer. 3.74e+11. What is the difference between the Payments (BoP, current US$) in Sub-Saharan Africa (all income levels) in 2007 and the Payments (BoP, current US$) in Paraguay in 2008?
Your response must be concise. 3.65e+11. What is the difference between the Payments (BoP, current US$) in Lao PDR in 2007 and the Payments (BoP, current US$) in Paraguay in 2008?
Keep it short and to the point. -9.31e+09. What is the difference between the Payments (BoP, current US$) of Middle income in 2007 and the Payments (BoP, current US$) of Sub-Saharan Africa (all income levels) in 2009?
Ensure brevity in your answer.  3.62e+12. What is the difference between the Payments (BoP, current US$) in Middle income in 2007 and the Payments (BoP, current US$) in Lao PDR in 2009?
Offer a terse response. 4.01e+12. What is the difference between the Payments (BoP, current US$) in Middle income in 2007 and the Payments (BoP, current US$) in Paraguay in 2009?
Offer a very short reply. 4.00e+12. What is the difference between the Payments (BoP, current US$) in Sub-Saharan Africa (all income levels) in 2007 and the Payments (BoP, current US$) in Lao PDR in 2009?
Provide a short and direct response. 3.74e+11. What is the difference between the Payments (BoP, current US$) in Sub-Saharan Africa (all income levels) in 2007 and the Payments (BoP, current US$) in Paraguay in 2009?
Your answer should be very brief. 3.67e+11. What is the difference between the Payments (BoP, current US$) in Lao PDR in 2007 and the Payments (BoP, current US$) in Paraguay in 2009?
Make the answer very short. -7.22e+09. What is the difference between the Payments (BoP, current US$) in Middle income in 2007 and the Payments (BoP, current US$) in Sub-Saharan Africa (all income levels) in 2010?
Provide a short and direct response. 3.55e+12. What is the difference between the Payments (BoP, current US$) of Middle income in 2007 and the Payments (BoP, current US$) of Lao PDR in 2010?
Your response must be concise. 4.01e+12. What is the difference between the Payments (BoP, current US$) in Middle income in 2007 and the Payments (BoP, current US$) in Paraguay in 2010?
Provide a succinct answer. 4.00e+12. What is the difference between the Payments (BoP, current US$) in Sub-Saharan Africa (all income levels) in 2007 and the Payments (BoP, current US$) in Lao PDR in 2010?
Your response must be concise. 3.73e+11. What is the difference between the Payments (BoP, current US$) in Sub-Saharan Africa (all income levels) in 2007 and the Payments (BoP, current US$) in Paraguay in 2010?
Your response must be concise. 3.64e+11. What is the difference between the Payments (BoP, current US$) of Lao PDR in 2007 and the Payments (BoP, current US$) of Paraguay in 2010?
Give a very brief answer. -1.05e+1. What is the difference between the Payments (BoP, current US$) in Middle income in 2007 and the Payments (BoP, current US$) in Sub-Saharan Africa (all income levels) in 2011?
Your answer should be compact. 3.46e+12. What is the difference between the Payments (BoP, current US$) in Middle income in 2007 and the Payments (BoP, current US$) in Lao PDR in 2011?
Provide a short and direct response. 4.01e+12. What is the difference between the Payments (BoP, current US$) in Middle income in 2007 and the Payments (BoP, current US$) in Paraguay in 2011?
Give a very brief answer. 4.00e+12. What is the difference between the Payments (BoP, current US$) in Sub-Saharan Africa (all income levels) in 2007 and the Payments (BoP, current US$) in Lao PDR in 2011?
Your answer should be very brief. 3.73e+11. What is the difference between the Payments (BoP, current US$) of Sub-Saharan Africa (all income levels) in 2007 and the Payments (BoP, current US$) of Paraguay in 2011?
Ensure brevity in your answer.  3.62e+11. What is the difference between the Payments (BoP, current US$) in Lao PDR in 2007 and the Payments (BoP, current US$) in Paraguay in 2011?
Give a very brief answer. -1.27e+1. What is the difference between the Payments (BoP, current US$) of Middle income in 2007 and the Payments (BoP, current US$) of Sub-Saharan Africa (all income levels) in 2012?
Your answer should be compact. 3.45e+12. What is the difference between the Payments (BoP, current US$) in Middle income in 2007 and the Payments (BoP, current US$) in Lao PDR in 2012?
Your response must be concise. 4.01e+12. What is the difference between the Payments (BoP, current US$) in Middle income in 2007 and the Payments (BoP, current US$) in Paraguay in 2012?
Ensure brevity in your answer.  4.00e+12. What is the difference between the Payments (BoP, current US$) in Sub-Saharan Africa (all income levels) in 2007 and the Payments (BoP, current US$) in Lao PDR in 2012?
Make the answer very short. 3.72e+11. What is the difference between the Payments (BoP, current US$) in Sub-Saharan Africa (all income levels) in 2007 and the Payments (BoP, current US$) in Paraguay in 2012?
Ensure brevity in your answer.  3.62e+11. What is the difference between the Payments (BoP, current US$) in Lao PDR in 2007 and the Payments (BoP, current US$) in Paraguay in 2012?
Your answer should be compact. -1.22e+1. What is the difference between the Payments (BoP, current US$) in Middle income in 2008 and the Payments (BoP, current US$) in Sub-Saharan Africa (all income levels) in 2009?
Your response must be concise. 4.53e+12. What is the difference between the Payments (BoP, current US$) of Middle income in 2008 and the Payments (BoP, current US$) of Lao PDR in 2009?
Offer a terse response. 4.91e+12. What is the difference between the Payments (BoP, current US$) of Middle income in 2008 and the Payments (BoP, current US$) of Paraguay in 2009?
Your answer should be compact. 4.91e+12. What is the difference between the Payments (BoP, current US$) of Sub-Saharan Africa (all income levels) in 2008 and the Payments (BoP, current US$) of Lao PDR in 2009?
Offer a terse response. 4.65e+11. What is the difference between the Payments (BoP, current US$) of Sub-Saharan Africa (all income levels) in 2008 and the Payments (BoP, current US$) of Paraguay in 2009?
Your response must be concise. 4.58e+11. What is the difference between the Payments (BoP, current US$) in Lao PDR in 2008 and the Payments (BoP, current US$) in Paraguay in 2009?
Provide a short and direct response. -6.83e+09. What is the difference between the Payments (BoP, current US$) of Middle income in 2008 and the Payments (BoP, current US$) of Sub-Saharan Africa (all income levels) in 2010?
Provide a succinct answer. 4.45e+12. What is the difference between the Payments (BoP, current US$) of Middle income in 2008 and the Payments (BoP, current US$) of Lao PDR in 2010?
Provide a short and direct response. 4.91e+12. What is the difference between the Payments (BoP, current US$) in Middle income in 2008 and the Payments (BoP, current US$) in Paraguay in 2010?
Your answer should be very brief. 4.90e+12. What is the difference between the Payments (BoP, current US$) of Sub-Saharan Africa (all income levels) in 2008 and the Payments (BoP, current US$) of Lao PDR in 2010?
Provide a succinct answer. 4.64e+11. What is the difference between the Payments (BoP, current US$) in Sub-Saharan Africa (all income levels) in 2008 and the Payments (BoP, current US$) in Paraguay in 2010?
Your answer should be compact. 4.55e+11. What is the difference between the Payments (BoP, current US$) of Lao PDR in 2008 and the Payments (BoP, current US$) of Paraguay in 2010?
Offer a terse response. -1.02e+1. What is the difference between the Payments (BoP, current US$) in Middle income in 2008 and the Payments (BoP, current US$) in Sub-Saharan Africa (all income levels) in 2011?
Keep it short and to the point. 4.36e+12. What is the difference between the Payments (BoP, current US$) in Middle income in 2008 and the Payments (BoP, current US$) in Lao PDR in 2011?
Keep it short and to the point. 4.91e+12. What is the difference between the Payments (BoP, current US$) in Middle income in 2008 and the Payments (BoP, current US$) in Paraguay in 2011?
Offer a very short reply. 4.90e+12. What is the difference between the Payments (BoP, current US$) in Sub-Saharan Africa (all income levels) in 2008 and the Payments (BoP, current US$) in Lao PDR in 2011?
Offer a very short reply. 4.63e+11. What is the difference between the Payments (BoP, current US$) of Sub-Saharan Africa (all income levels) in 2008 and the Payments (BoP, current US$) of Paraguay in 2011?
Provide a short and direct response. 4.52e+11. What is the difference between the Payments (BoP, current US$) of Lao PDR in 2008 and the Payments (BoP, current US$) of Paraguay in 2011?
Your answer should be compact. -1.24e+1. What is the difference between the Payments (BoP, current US$) of Middle income in 2008 and the Payments (BoP, current US$) of Sub-Saharan Africa (all income levels) in 2012?
Offer a very short reply. 4.35e+12. What is the difference between the Payments (BoP, current US$) of Middle income in 2008 and the Payments (BoP, current US$) of Lao PDR in 2012?
Provide a succinct answer. 4.91e+12. What is the difference between the Payments (BoP, current US$) of Middle income in 2008 and the Payments (BoP, current US$) of Paraguay in 2012?
Make the answer very short. 4.90e+12. What is the difference between the Payments (BoP, current US$) of Sub-Saharan Africa (all income levels) in 2008 and the Payments (BoP, current US$) of Lao PDR in 2012?
Ensure brevity in your answer.  4.63e+11. What is the difference between the Payments (BoP, current US$) of Sub-Saharan Africa (all income levels) in 2008 and the Payments (BoP, current US$) of Paraguay in 2012?
Your response must be concise. 4.53e+11. What is the difference between the Payments (BoP, current US$) in Lao PDR in 2008 and the Payments (BoP, current US$) in Paraguay in 2012?
Make the answer very short. -1.18e+1. What is the difference between the Payments (BoP, current US$) of Middle income in 2009 and the Payments (BoP, current US$) of Sub-Saharan Africa (all income levels) in 2010?
Offer a very short reply. 3.65e+12. What is the difference between the Payments (BoP, current US$) of Middle income in 2009 and the Payments (BoP, current US$) of Lao PDR in 2010?
Ensure brevity in your answer.  4.12e+12. What is the difference between the Payments (BoP, current US$) in Middle income in 2009 and the Payments (BoP, current US$) in Paraguay in 2010?
Your answer should be very brief. 4.11e+12. What is the difference between the Payments (BoP, current US$) of Sub-Saharan Africa (all income levels) in 2009 and the Payments (BoP, current US$) of Lao PDR in 2010?
Offer a very short reply. 3.85e+11. What is the difference between the Payments (BoP, current US$) of Sub-Saharan Africa (all income levels) in 2009 and the Payments (BoP, current US$) of Paraguay in 2010?
Your response must be concise. 3.76e+11. What is the difference between the Payments (BoP, current US$) of Lao PDR in 2009 and the Payments (BoP, current US$) of Paraguay in 2010?
Your answer should be compact. -1.01e+1. What is the difference between the Payments (BoP, current US$) of Middle income in 2009 and the Payments (BoP, current US$) of Sub-Saharan Africa (all income levels) in 2011?
Make the answer very short. 3.56e+12. What is the difference between the Payments (BoP, current US$) in Middle income in 2009 and the Payments (BoP, current US$) in Lao PDR in 2011?
Provide a short and direct response. 4.12e+12. What is the difference between the Payments (BoP, current US$) in Middle income in 2009 and the Payments (BoP, current US$) in Paraguay in 2011?
Provide a succinct answer. 4.10e+12. What is the difference between the Payments (BoP, current US$) of Sub-Saharan Africa (all income levels) in 2009 and the Payments (BoP, current US$) of Lao PDR in 2011?
Your response must be concise. 3.85e+11. What is the difference between the Payments (BoP, current US$) in Sub-Saharan Africa (all income levels) in 2009 and the Payments (BoP, current US$) in Paraguay in 2011?
Offer a very short reply. 3.74e+11. What is the difference between the Payments (BoP, current US$) in Lao PDR in 2009 and the Payments (BoP, current US$) in Paraguay in 2011?
Ensure brevity in your answer.  -1.23e+1. What is the difference between the Payments (BoP, current US$) in Middle income in 2009 and the Payments (BoP, current US$) in Sub-Saharan Africa (all income levels) in 2012?
Provide a short and direct response. 3.55e+12. What is the difference between the Payments (BoP, current US$) in Middle income in 2009 and the Payments (BoP, current US$) in Lao PDR in 2012?
Offer a terse response. 4.11e+12. What is the difference between the Payments (BoP, current US$) in Middle income in 2009 and the Payments (BoP, current US$) in Paraguay in 2012?
Offer a terse response. 4.10e+12. What is the difference between the Payments (BoP, current US$) in Sub-Saharan Africa (all income levels) in 2009 and the Payments (BoP, current US$) in Lao PDR in 2012?
Offer a very short reply. 3.84e+11. What is the difference between the Payments (BoP, current US$) of Sub-Saharan Africa (all income levels) in 2009 and the Payments (BoP, current US$) of Paraguay in 2012?
Provide a short and direct response. 3.74e+11. What is the difference between the Payments (BoP, current US$) of Lao PDR in 2009 and the Payments (BoP, current US$) of Paraguay in 2012?
Provide a short and direct response. -1.17e+1. What is the difference between the Payments (BoP, current US$) in Middle income in 2010 and the Payments (BoP, current US$) in Sub-Saharan Africa (all income levels) in 2011?
Make the answer very short. 4.73e+12. What is the difference between the Payments (BoP, current US$) in Middle income in 2010 and the Payments (BoP, current US$) in Lao PDR in 2011?
Your answer should be compact. 5.28e+12. What is the difference between the Payments (BoP, current US$) in Middle income in 2010 and the Payments (BoP, current US$) in Paraguay in 2011?
Provide a succinct answer. 5.27e+12. What is the difference between the Payments (BoP, current US$) in Sub-Saharan Africa (all income levels) in 2010 and the Payments (BoP, current US$) in Lao PDR in 2011?
Ensure brevity in your answer.  4.62e+11. What is the difference between the Payments (BoP, current US$) of Sub-Saharan Africa (all income levels) in 2010 and the Payments (BoP, current US$) of Paraguay in 2011?
Your response must be concise. 4.51e+11. What is the difference between the Payments (BoP, current US$) of Lao PDR in 2010 and the Payments (BoP, current US$) of Paraguay in 2011?
Offer a very short reply. -1.15e+1. What is the difference between the Payments (BoP, current US$) of Middle income in 2010 and the Payments (BoP, current US$) of Sub-Saharan Africa (all income levels) in 2012?
Offer a very short reply. 4.72e+12. What is the difference between the Payments (BoP, current US$) of Middle income in 2010 and the Payments (BoP, current US$) of Lao PDR in 2012?
Keep it short and to the point. 5.28e+12. What is the difference between the Payments (BoP, current US$) in Middle income in 2010 and the Payments (BoP, current US$) in Paraguay in 2012?
Your response must be concise. 5.27e+12. What is the difference between the Payments (BoP, current US$) of Sub-Saharan Africa (all income levels) in 2010 and the Payments (BoP, current US$) of Lao PDR in 2012?
Offer a very short reply. 4.61e+11. What is the difference between the Payments (BoP, current US$) of Sub-Saharan Africa (all income levels) in 2010 and the Payments (BoP, current US$) of Paraguay in 2012?
Your answer should be very brief. 4.51e+11. What is the difference between the Payments (BoP, current US$) of Lao PDR in 2010 and the Payments (BoP, current US$) of Paraguay in 2012?
Ensure brevity in your answer.  -1.09e+1. What is the difference between the Payments (BoP, current US$) of Middle income in 2011 and the Payments (BoP, current US$) of Sub-Saharan Africa (all income levels) in 2012?
Provide a succinct answer. 5.92e+12. What is the difference between the Payments (BoP, current US$) in Middle income in 2011 and the Payments (BoP, current US$) in Lao PDR in 2012?
Make the answer very short. 6.48e+12. What is the difference between the Payments (BoP, current US$) in Middle income in 2011 and the Payments (BoP, current US$) in Paraguay in 2012?
Your answer should be very brief. 6.47e+12. What is the difference between the Payments (BoP, current US$) of Sub-Saharan Africa (all income levels) in 2011 and the Payments (BoP, current US$) of Lao PDR in 2012?
Your answer should be compact. 5.51e+11. What is the difference between the Payments (BoP, current US$) in Sub-Saharan Africa (all income levels) in 2011 and the Payments (BoP, current US$) in Paraguay in 2012?
Offer a very short reply. 5.41e+11. What is the difference between the Payments (BoP, current US$) in Lao PDR in 2011 and the Payments (BoP, current US$) in Paraguay in 2012?
Your response must be concise. -1.05e+1. What is the average Payments (BoP, current US$) in Middle income per year?
Your response must be concise. 4.72e+12. What is the average Payments (BoP, current US$) of Sub-Saharan Africa (all income levels) per year?
Keep it short and to the point. 4.20e+11. What is the average Payments (BoP, current US$) of Lao PDR per year?
Provide a short and direct response. 1.95e+09. What is the average Payments (BoP, current US$) of Paraguay per year?
Offer a very short reply. 9.72e+09. In the year 2005, what is the difference between the Payments (BoP, current US$) of Middle income and Payments (BoP, current US$) of Sub-Saharan Africa (all income levels)?
Your answer should be very brief. 2.55e+12. In the year 2005, what is the difference between the Payments (BoP, current US$) of Middle income and Payments (BoP, current US$) of Lao PDR?
Give a very brief answer. 2.80e+12. In the year 2005, what is the difference between the Payments (BoP, current US$) of Middle income and Payments (BoP, current US$) of Paraguay?
Ensure brevity in your answer.  2.80e+12. In the year 2005, what is the difference between the Payments (BoP, current US$) of Sub-Saharan Africa (all income levels) and Payments (BoP, current US$) of Lao PDR?
Give a very brief answer. 2.46e+11. In the year 2005, what is the difference between the Payments (BoP, current US$) of Sub-Saharan Africa (all income levels) and Payments (BoP, current US$) of Paraguay?
Keep it short and to the point. 2.42e+11. In the year 2005, what is the difference between the Payments (BoP, current US$) in Lao PDR and Payments (BoP, current US$) in Paraguay?
Provide a succinct answer. -4.47e+09. In the year 2006, what is the difference between the Payments (BoP, current US$) in Middle income and Payments (BoP, current US$) in Sub-Saharan Africa (all income levels)?
Offer a very short reply. 2.99e+12. In the year 2006, what is the difference between the Payments (BoP, current US$) in Middle income and Payments (BoP, current US$) in Lao PDR?
Your response must be concise. 3.28e+12. In the year 2006, what is the difference between the Payments (BoP, current US$) in Middle income and Payments (BoP, current US$) in Paraguay?
Offer a terse response. 3.28e+12. In the year 2006, what is the difference between the Payments (BoP, current US$) in Sub-Saharan Africa (all income levels) and Payments (BoP, current US$) in Lao PDR?
Give a very brief answer. 2.93e+11. In the year 2006, what is the difference between the Payments (BoP, current US$) in Sub-Saharan Africa (all income levels) and Payments (BoP, current US$) in Paraguay?
Keep it short and to the point. 2.88e+11. In the year 2006, what is the difference between the Payments (BoP, current US$) of Lao PDR and Payments (BoP, current US$) of Paraguay?
Offer a terse response. -5.53e+09. In the year 2007, what is the difference between the Payments (BoP, current US$) in Middle income and Payments (BoP, current US$) in Sub-Saharan Africa (all income levels)?
Offer a terse response. 3.64e+12. In the year 2007, what is the difference between the Payments (BoP, current US$) in Middle income and Payments (BoP, current US$) in Lao PDR?
Your answer should be compact. 4.01e+12. In the year 2007, what is the difference between the Payments (BoP, current US$) of Middle income and Payments (BoP, current US$) of Paraguay?
Your answer should be very brief. 4.00e+12. In the year 2007, what is the difference between the Payments (BoP, current US$) in Sub-Saharan Africa (all income levels) and Payments (BoP, current US$) in Lao PDR?
Provide a short and direct response. 3.74e+11. In the year 2007, what is the difference between the Payments (BoP, current US$) in Sub-Saharan Africa (all income levels) and Payments (BoP, current US$) in Paraguay?
Provide a succinct answer. 3.68e+11. In the year 2007, what is the difference between the Payments (BoP, current US$) in Lao PDR and Payments (BoP, current US$) in Paraguay?
Make the answer very short. -6.36e+09. In the year 2008, what is the difference between the Payments (BoP, current US$) of Middle income and Payments (BoP, current US$) of Sub-Saharan Africa (all income levels)?
Provide a succinct answer. 4.45e+12. In the year 2008, what is the difference between the Payments (BoP, current US$) in Middle income and Payments (BoP, current US$) in Lao PDR?
Your answer should be compact. 4.91e+12. In the year 2008, what is the difference between the Payments (BoP, current US$) of Middle income and Payments (BoP, current US$) of Paraguay?
Make the answer very short. 4.91e+12. In the year 2008, what is the difference between the Payments (BoP, current US$) of Sub-Saharan Africa (all income levels) and Payments (BoP, current US$) of Lao PDR?
Keep it short and to the point. 4.65e+11. In the year 2008, what is the difference between the Payments (BoP, current US$) of Sub-Saharan Africa (all income levels) and Payments (BoP, current US$) of Paraguay?
Provide a succinct answer. 4.56e+11. In the year 2008, what is the difference between the Payments (BoP, current US$) of Lao PDR and Payments (BoP, current US$) of Paraguay?
Your answer should be very brief. -8.92e+09. In the year 2009, what is the difference between the Payments (BoP, current US$) in Middle income and Payments (BoP, current US$) in Sub-Saharan Africa (all income levels)?
Your answer should be compact. 3.73e+12. In the year 2009, what is the difference between the Payments (BoP, current US$) in Middle income and Payments (BoP, current US$) in Lao PDR?
Your response must be concise. 4.12e+12. In the year 2009, what is the difference between the Payments (BoP, current US$) of Middle income and Payments (BoP, current US$) of Paraguay?
Keep it short and to the point. 4.11e+12. In the year 2009, what is the difference between the Payments (BoP, current US$) of Sub-Saharan Africa (all income levels) and Payments (BoP, current US$) of Lao PDR?
Offer a terse response. 3.86e+11. In the year 2009, what is the difference between the Payments (BoP, current US$) in Sub-Saharan Africa (all income levels) and Payments (BoP, current US$) in Paraguay?
Give a very brief answer. 3.79e+11. In the year 2009, what is the difference between the Payments (BoP, current US$) of Lao PDR and Payments (BoP, current US$) of Paraguay?
Keep it short and to the point. -6.74e+09. In the year 2010, what is the difference between the Payments (BoP, current US$) of Middle income and Payments (BoP, current US$) of Sub-Saharan Africa (all income levels)?
Ensure brevity in your answer.  4.82e+12. In the year 2010, what is the difference between the Payments (BoP, current US$) in Middle income and Payments (BoP, current US$) in Lao PDR?
Ensure brevity in your answer.  5.28e+12. In the year 2010, what is the difference between the Payments (BoP, current US$) of Middle income and Payments (BoP, current US$) of Paraguay?
Your response must be concise. 5.27e+12. In the year 2010, what is the difference between the Payments (BoP, current US$) in Sub-Saharan Africa (all income levels) and Payments (BoP, current US$) in Lao PDR?
Make the answer very short. 4.62e+11. In the year 2010, what is the difference between the Payments (BoP, current US$) of Sub-Saharan Africa (all income levels) and Payments (BoP, current US$) of Paraguay?
Your answer should be compact. 4.53e+11. In the year 2010, what is the difference between the Payments (BoP, current US$) in Lao PDR and Payments (BoP, current US$) in Paraguay?
Offer a very short reply. -9.29e+09. In the year 2011, what is the difference between the Payments (BoP, current US$) in Middle income and Payments (BoP, current US$) in Sub-Saharan Africa (all income levels)?
Your response must be concise. 5.93e+12. In the year 2011, what is the difference between the Payments (BoP, current US$) in Middle income and Payments (BoP, current US$) in Lao PDR?
Your answer should be compact. 6.48e+12. In the year 2011, what is the difference between the Payments (BoP, current US$) in Middle income and Payments (BoP, current US$) in Paraguay?
Give a very brief answer. 6.47e+12. In the year 2011, what is the difference between the Payments (BoP, current US$) of Sub-Saharan Africa (all income levels) and Payments (BoP, current US$) of Lao PDR?
Make the answer very short. 5.51e+11. In the year 2011, what is the difference between the Payments (BoP, current US$) in Sub-Saharan Africa (all income levels) and Payments (BoP, current US$) in Paraguay?
Your response must be concise. 5.40e+11. In the year 2011, what is the difference between the Payments (BoP, current US$) in Lao PDR and Payments (BoP, current US$) in Paraguay?
Make the answer very short. -1.11e+1. In the year 2012, what is the difference between the Payments (BoP, current US$) in Middle income and Payments (BoP, current US$) in Sub-Saharan Africa (all income levels)?
Your response must be concise. 6.27e+12. In the year 2012, what is the difference between the Payments (BoP, current US$) of Middle income and Payments (BoP, current US$) of Lao PDR?
Keep it short and to the point. 6.83e+12. In the year 2012, what is the difference between the Payments (BoP, current US$) in Middle income and Payments (BoP, current US$) in Paraguay?
Your answer should be very brief. 6.82e+12. In the year 2012, what is the difference between the Payments (BoP, current US$) in Sub-Saharan Africa (all income levels) and Payments (BoP, current US$) in Lao PDR?
Your answer should be very brief. 5.62e+11. In the year 2012, what is the difference between the Payments (BoP, current US$) in Sub-Saharan Africa (all income levels) and Payments (BoP, current US$) in Paraguay?
Give a very brief answer. 5.53e+11. In the year 2012, what is the difference between the Payments (BoP, current US$) in Lao PDR and Payments (BoP, current US$) in Paraguay?
Keep it short and to the point. -9.79e+09. What is the ratio of the Payments (BoP, current US$) of Middle income in 2005 to that in 2006?
Offer a terse response. 0.85. What is the ratio of the Payments (BoP, current US$) of Sub-Saharan Africa (all income levels) in 2005 to that in 2006?
Give a very brief answer. 0.84. What is the ratio of the Payments (BoP, current US$) in Lao PDR in 2005 to that in 2006?
Offer a terse response. 0.86. What is the ratio of the Payments (BoP, current US$) of Paraguay in 2005 to that in 2006?
Offer a very short reply. 0.82. What is the ratio of the Payments (BoP, current US$) of Middle income in 2005 to that in 2007?
Your answer should be very brief. 0.7. What is the ratio of the Payments (BoP, current US$) in Sub-Saharan Africa (all income levels) in 2005 to that in 2007?
Your response must be concise. 0.66. What is the ratio of the Payments (BoP, current US$) of Lao PDR in 2005 to that in 2007?
Offer a terse response. 0.83. What is the ratio of the Payments (BoP, current US$) in Paraguay in 2005 to that in 2007?
Offer a very short reply. 0.72. What is the ratio of the Payments (BoP, current US$) in Middle income in 2005 to that in 2008?
Your answer should be very brief. 0.57. What is the ratio of the Payments (BoP, current US$) in Sub-Saharan Africa (all income levels) in 2005 to that in 2008?
Your response must be concise. 0.53. What is the ratio of the Payments (BoP, current US$) of Lao PDR in 2005 to that in 2008?
Keep it short and to the point. 0.63. What is the ratio of the Payments (BoP, current US$) of Paraguay in 2005 to that in 2008?
Provide a succinct answer. 0.52. What is the ratio of the Payments (BoP, current US$) in Middle income in 2005 to that in 2009?
Ensure brevity in your answer.  0.68. What is the ratio of the Payments (BoP, current US$) of Sub-Saharan Africa (all income levels) in 2005 to that in 2009?
Make the answer very short. 0.64. What is the ratio of the Payments (BoP, current US$) in Lao PDR in 2005 to that in 2009?
Offer a very short reply. 0.6. What is the ratio of the Payments (BoP, current US$) of Paraguay in 2005 to that in 2009?
Provide a short and direct response. 0.65. What is the ratio of the Payments (BoP, current US$) of Middle income in 2005 to that in 2010?
Offer a terse response. 0.53. What is the ratio of the Payments (BoP, current US$) in Sub-Saharan Africa (all income levels) in 2005 to that in 2010?
Ensure brevity in your answer.  0.53. What is the ratio of the Payments (BoP, current US$) of Lao PDR in 2005 to that in 2010?
Your answer should be compact. 0.41. What is the ratio of the Payments (BoP, current US$) of Paraguay in 2005 to that in 2010?
Your answer should be very brief. 0.47. What is the ratio of the Payments (BoP, current US$) of Middle income in 2005 to that in 2011?
Keep it short and to the point. 0.43. What is the ratio of the Payments (BoP, current US$) of Sub-Saharan Africa (all income levels) in 2005 to that in 2011?
Make the answer very short. 0.45. What is the ratio of the Payments (BoP, current US$) in Lao PDR in 2005 to that in 2011?
Your response must be concise. 0.35. What is the ratio of the Payments (BoP, current US$) of Paraguay in 2005 to that in 2011?
Give a very brief answer. 0.39. What is the ratio of the Payments (BoP, current US$) in Middle income in 2005 to that in 2012?
Keep it short and to the point. 0.41. What is the ratio of the Payments (BoP, current US$) in Sub-Saharan Africa (all income levels) in 2005 to that in 2012?
Provide a succinct answer. 0.44. What is the ratio of the Payments (BoP, current US$) in Lao PDR in 2005 to that in 2012?
Your answer should be very brief. 0.28. What is the ratio of the Payments (BoP, current US$) in Paraguay in 2005 to that in 2012?
Provide a succinct answer. 0.41. What is the ratio of the Payments (BoP, current US$) in Middle income in 2006 to that in 2007?
Provide a short and direct response. 0.82. What is the ratio of the Payments (BoP, current US$) in Sub-Saharan Africa (all income levels) in 2006 to that in 2007?
Make the answer very short. 0.78. What is the ratio of the Payments (BoP, current US$) of Lao PDR in 2006 to that in 2007?
Your answer should be very brief. 0.98. What is the ratio of the Payments (BoP, current US$) of Paraguay in 2006 to that in 2007?
Keep it short and to the point. 0.89. What is the ratio of the Payments (BoP, current US$) of Middle income in 2006 to that in 2008?
Ensure brevity in your answer.  0.67. What is the ratio of the Payments (BoP, current US$) in Sub-Saharan Africa (all income levels) in 2006 to that in 2008?
Your answer should be very brief. 0.63. What is the ratio of the Payments (BoP, current US$) of Lao PDR in 2006 to that in 2008?
Provide a succinct answer. 0.74. What is the ratio of the Payments (BoP, current US$) in Paraguay in 2006 to that in 2008?
Your answer should be very brief. 0.64. What is the ratio of the Payments (BoP, current US$) of Middle income in 2006 to that in 2009?
Provide a succinct answer. 0.8. What is the ratio of the Payments (BoP, current US$) of Sub-Saharan Africa (all income levels) in 2006 to that in 2009?
Your answer should be very brief. 0.76. What is the ratio of the Payments (BoP, current US$) of Lao PDR in 2006 to that in 2009?
Offer a very short reply. 0.7. What is the ratio of the Payments (BoP, current US$) in Paraguay in 2006 to that in 2009?
Give a very brief answer. 0.8. What is the ratio of the Payments (BoP, current US$) of Middle income in 2006 to that in 2010?
Ensure brevity in your answer.  0.62. What is the ratio of the Payments (BoP, current US$) of Sub-Saharan Africa (all income levels) in 2006 to that in 2010?
Provide a succinct answer. 0.63. What is the ratio of the Payments (BoP, current US$) in Lao PDR in 2006 to that in 2010?
Give a very brief answer. 0.48. What is the ratio of the Payments (BoP, current US$) of Paraguay in 2006 to that in 2010?
Offer a very short reply. 0.57. What is the ratio of the Payments (BoP, current US$) of Middle income in 2006 to that in 2011?
Make the answer very short. 0.51. What is the ratio of the Payments (BoP, current US$) of Sub-Saharan Africa (all income levels) in 2006 to that in 2011?
Ensure brevity in your answer.  0.53. What is the ratio of the Payments (BoP, current US$) of Lao PDR in 2006 to that in 2011?
Make the answer very short. 0.41. What is the ratio of the Payments (BoP, current US$) in Paraguay in 2006 to that in 2011?
Offer a terse response. 0.48. What is the ratio of the Payments (BoP, current US$) of Middle income in 2006 to that in 2012?
Give a very brief answer. 0.48. What is the ratio of the Payments (BoP, current US$) of Sub-Saharan Africa (all income levels) in 2006 to that in 2012?
Give a very brief answer. 0.52. What is the ratio of the Payments (BoP, current US$) of Lao PDR in 2006 to that in 2012?
Keep it short and to the point. 0.33. What is the ratio of the Payments (BoP, current US$) of Paraguay in 2006 to that in 2012?
Ensure brevity in your answer.  0.5. What is the ratio of the Payments (BoP, current US$) of Middle income in 2007 to that in 2008?
Offer a very short reply. 0.82. What is the ratio of the Payments (BoP, current US$) in Sub-Saharan Africa (all income levels) in 2007 to that in 2008?
Offer a very short reply. 0.81. What is the ratio of the Payments (BoP, current US$) in Lao PDR in 2007 to that in 2008?
Keep it short and to the point. 0.76. What is the ratio of the Payments (BoP, current US$) in Paraguay in 2007 to that in 2008?
Keep it short and to the point. 0.72. What is the ratio of the Payments (BoP, current US$) of Sub-Saharan Africa (all income levels) in 2007 to that in 2009?
Make the answer very short. 0.97. What is the ratio of the Payments (BoP, current US$) of Lao PDR in 2007 to that in 2009?
Keep it short and to the point. 0.71. What is the ratio of the Payments (BoP, current US$) in Paraguay in 2007 to that in 2009?
Ensure brevity in your answer.  0.9. What is the ratio of the Payments (BoP, current US$) of Middle income in 2007 to that in 2010?
Provide a succinct answer. 0.76. What is the ratio of the Payments (BoP, current US$) of Sub-Saharan Africa (all income levels) in 2007 to that in 2010?
Keep it short and to the point. 0.81. What is the ratio of the Payments (BoP, current US$) of Lao PDR in 2007 to that in 2010?
Keep it short and to the point. 0.49. What is the ratio of the Payments (BoP, current US$) of Paraguay in 2007 to that in 2010?
Give a very brief answer. 0.64. What is the ratio of the Payments (BoP, current US$) in Middle income in 2007 to that in 2011?
Make the answer very short. 0.62. What is the ratio of the Payments (BoP, current US$) of Sub-Saharan Africa (all income levels) in 2007 to that in 2011?
Make the answer very short. 0.68. What is the ratio of the Payments (BoP, current US$) in Lao PDR in 2007 to that in 2011?
Provide a short and direct response. 0.42. What is the ratio of the Payments (BoP, current US$) of Paraguay in 2007 to that in 2011?
Give a very brief answer. 0.54. What is the ratio of the Payments (BoP, current US$) of Middle income in 2007 to that in 2012?
Offer a terse response. 0.59. What is the ratio of the Payments (BoP, current US$) of Sub-Saharan Africa (all income levels) in 2007 to that in 2012?
Ensure brevity in your answer.  0.66. What is the ratio of the Payments (BoP, current US$) in Lao PDR in 2007 to that in 2012?
Offer a terse response. 0.34. What is the ratio of the Payments (BoP, current US$) in Paraguay in 2007 to that in 2012?
Offer a terse response. 0.57. What is the ratio of the Payments (BoP, current US$) in Middle income in 2008 to that in 2009?
Ensure brevity in your answer.  1.19. What is the ratio of the Payments (BoP, current US$) in Sub-Saharan Africa (all income levels) in 2008 to that in 2009?
Make the answer very short. 1.2. What is the ratio of the Payments (BoP, current US$) of Lao PDR in 2008 to that in 2009?
Provide a short and direct response. 0.94. What is the ratio of the Payments (BoP, current US$) in Paraguay in 2008 to that in 2009?
Provide a succinct answer. 1.25. What is the ratio of the Payments (BoP, current US$) of Middle income in 2008 to that in 2010?
Your answer should be very brief. 0.93. What is the ratio of the Payments (BoP, current US$) in Lao PDR in 2008 to that in 2010?
Provide a short and direct response. 0.65. What is the ratio of the Payments (BoP, current US$) in Paraguay in 2008 to that in 2010?
Your answer should be very brief. 0.89. What is the ratio of the Payments (BoP, current US$) of Middle income in 2008 to that in 2011?
Ensure brevity in your answer.  0.76. What is the ratio of the Payments (BoP, current US$) in Sub-Saharan Africa (all income levels) in 2008 to that in 2011?
Provide a short and direct response. 0.84. What is the ratio of the Payments (BoP, current US$) in Lao PDR in 2008 to that in 2011?
Offer a terse response. 0.55. What is the ratio of the Payments (BoP, current US$) of Paraguay in 2008 to that in 2011?
Provide a short and direct response. 0.75. What is the ratio of the Payments (BoP, current US$) of Middle income in 2008 to that in 2012?
Ensure brevity in your answer.  0.72. What is the ratio of the Payments (BoP, current US$) in Sub-Saharan Africa (all income levels) in 2008 to that in 2012?
Your answer should be very brief. 0.82. What is the ratio of the Payments (BoP, current US$) in Lao PDR in 2008 to that in 2012?
Offer a terse response. 0.44. What is the ratio of the Payments (BoP, current US$) of Paraguay in 2008 to that in 2012?
Provide a short and direct response. 0.79. What is the ratio of the Payments (BoP, current US$) of Middle income in 2009 to that in 2010?
Give a very brief answer. 0.78. What is the ratio of the Payments (BoP, current US$) in Sub-Saharan Africa (all income levels) in 2009 to that in 2010?
Offer a terse response. 0.83. What is the ratio of the Payments (BoP, current US$) in Lao PDR in 2009 to that in 2010?
Ensure brevity in your answer.  0.69. What is the ratio of the Payments (BoP, current US$) of Paraguay in 2009 to that in 2010?
Offer a terse response. 0.72. What is the ratio of the Payments (BoP, current US$) in Middle income in 2009 to that in 2011?
Provide a succinct answer. 0.64. What is the ratio of the Payments (BoP, current US$) in Sub-Saharan Africa (all income levels) in 2009 to that in 2011?
Ensure brevity in your answer.  0.7. What is the ratio of the Payments (BoP, current US$) of Lao PDR in 2009 to that in 2011?
Make the answer very short. 0.58. What is the ratio of the Payments (BoP, current US$) in Paraguay in 2009 to that in 2011?
Offer a very short reply. 0.6. What is the ratio of the Payments (BoP, current US$) of Middle income in 2009 to that in 2012?
Give a very brief answer. 0.6. What is the ratio of the Payments (BoP, current US$) in Sub-Saharan Africa (all income levels) in 2009 to that in 2012?
Offer a very short reply. 0.69. What is the ratio of the Payments (BoP, current US$) in Lao PDR in 2009 to that in 2012?
Give a very brief answer. 0.47. What is the ratio of the Payments (BoP, current US$) of Paraguay in 2009 to that in 2012?
Provide a short and direct response. 0.63. What is the ratio of the Payments (BoP, current US$) of Middle income in 2010 to that in 2011?
Make the answer very short. 0.81. What is the ratio of the Payments (BoP, current US$) of Sub-Saharan Africa (all income levels) in 2010 to that in 2011?
Offer a very short reply. 0.84. What is the ratio of the Payments (BoP, current US$) of Lao PDR in 2010 to that in 2011?
Give a very brief answer. 0.85. What is the ratio of the Payments (BoP, current US$) in Paraguay in 2010 to that in 2011?
Your answer should be very brief. 0.84. What is the ratio of the Payments (BoP, current US$) in Middle income in 2010 to that in 2012?
Provide a short and direct response. 0.77. What is the ratio of the Payments (BoP, current US$) in Sub-Saharan Africa (all income levels) in 2010 to that in 2012?
Offer a terse response. 0.82. What is the ratio of the Payments (BoP, current US$) in Lao PDR in 2010 to that in 2012?
Offer a very short reply. 0.69. What is the ratio of the Payments (BoP, current US$) of Paraguay in 2010 to that in 2012?
Give a very brief answer. 0.88. What is the ratio of the Payments (BoP, current US$) of Middle income in 2011 to that in 2012?
Provide a succinct answer. 0.95. What is the ratio of the Payments (BoP, current US$) in Sub-Saharan Africa (all income levels) in 2011 to that in 2012?
Offer a very short reply. 0.98. What is the ratio of the Payments (BoP, current US$) of Lao PDR in 2011 to that in 2012?
Offer a very short reply. 0.8. What is the ratio of the Payments (BoP, current US$) of Paraguay in 2011 to that in 2012?
Your response must be concise. 1.04. What is the difference between the highest and the second highest Payments (BoP, current US$) of Middle income?
Your response must be concise. 3.51e+11. What is the difference between the highest and the second highest Payments (BoP, current US$) of Sub-Saharan Africa (all income levels)?
Offer a very short reply. 1.19e+1. What is the difference between the highest and the second highest Payments (BoP, current US$) in Lao PDR?
Make the answer very short. 7.01e+08. What is the difference between the highest and the second highest Payments (BoP, current US$) in Paraguay?
Offer a very short reply. 5.66e+08. What is the difference between the highest and the lowest Payments (BoP, current US$) of Middle income?
Keep it short and to the point. 4.03e+12. What is the difference between the highest and the lowest Payments (BoP, current US$) in Sub-Saharan Africa (all income levels)?
Provide a short and direct response. 3.19e+11. What is the difference between the highest and the lowest Payments (BoP, current US$) in Lao PDR?
Your answer should be very brief. 2.58e+09. What is the difference between the highest and the lowest Payments (BoP, current US$) in Paraguay?
Keep it short and to the point. 8.47e+09. 